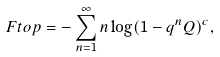<formula> <loc_0><loc_0><loc_500><loc_500>\ F t o p = - \sum _ { n = 1 } ^ { \infty } n \log ( 1 - q ^ { n } Q ) ^ { c } ,</formula> 